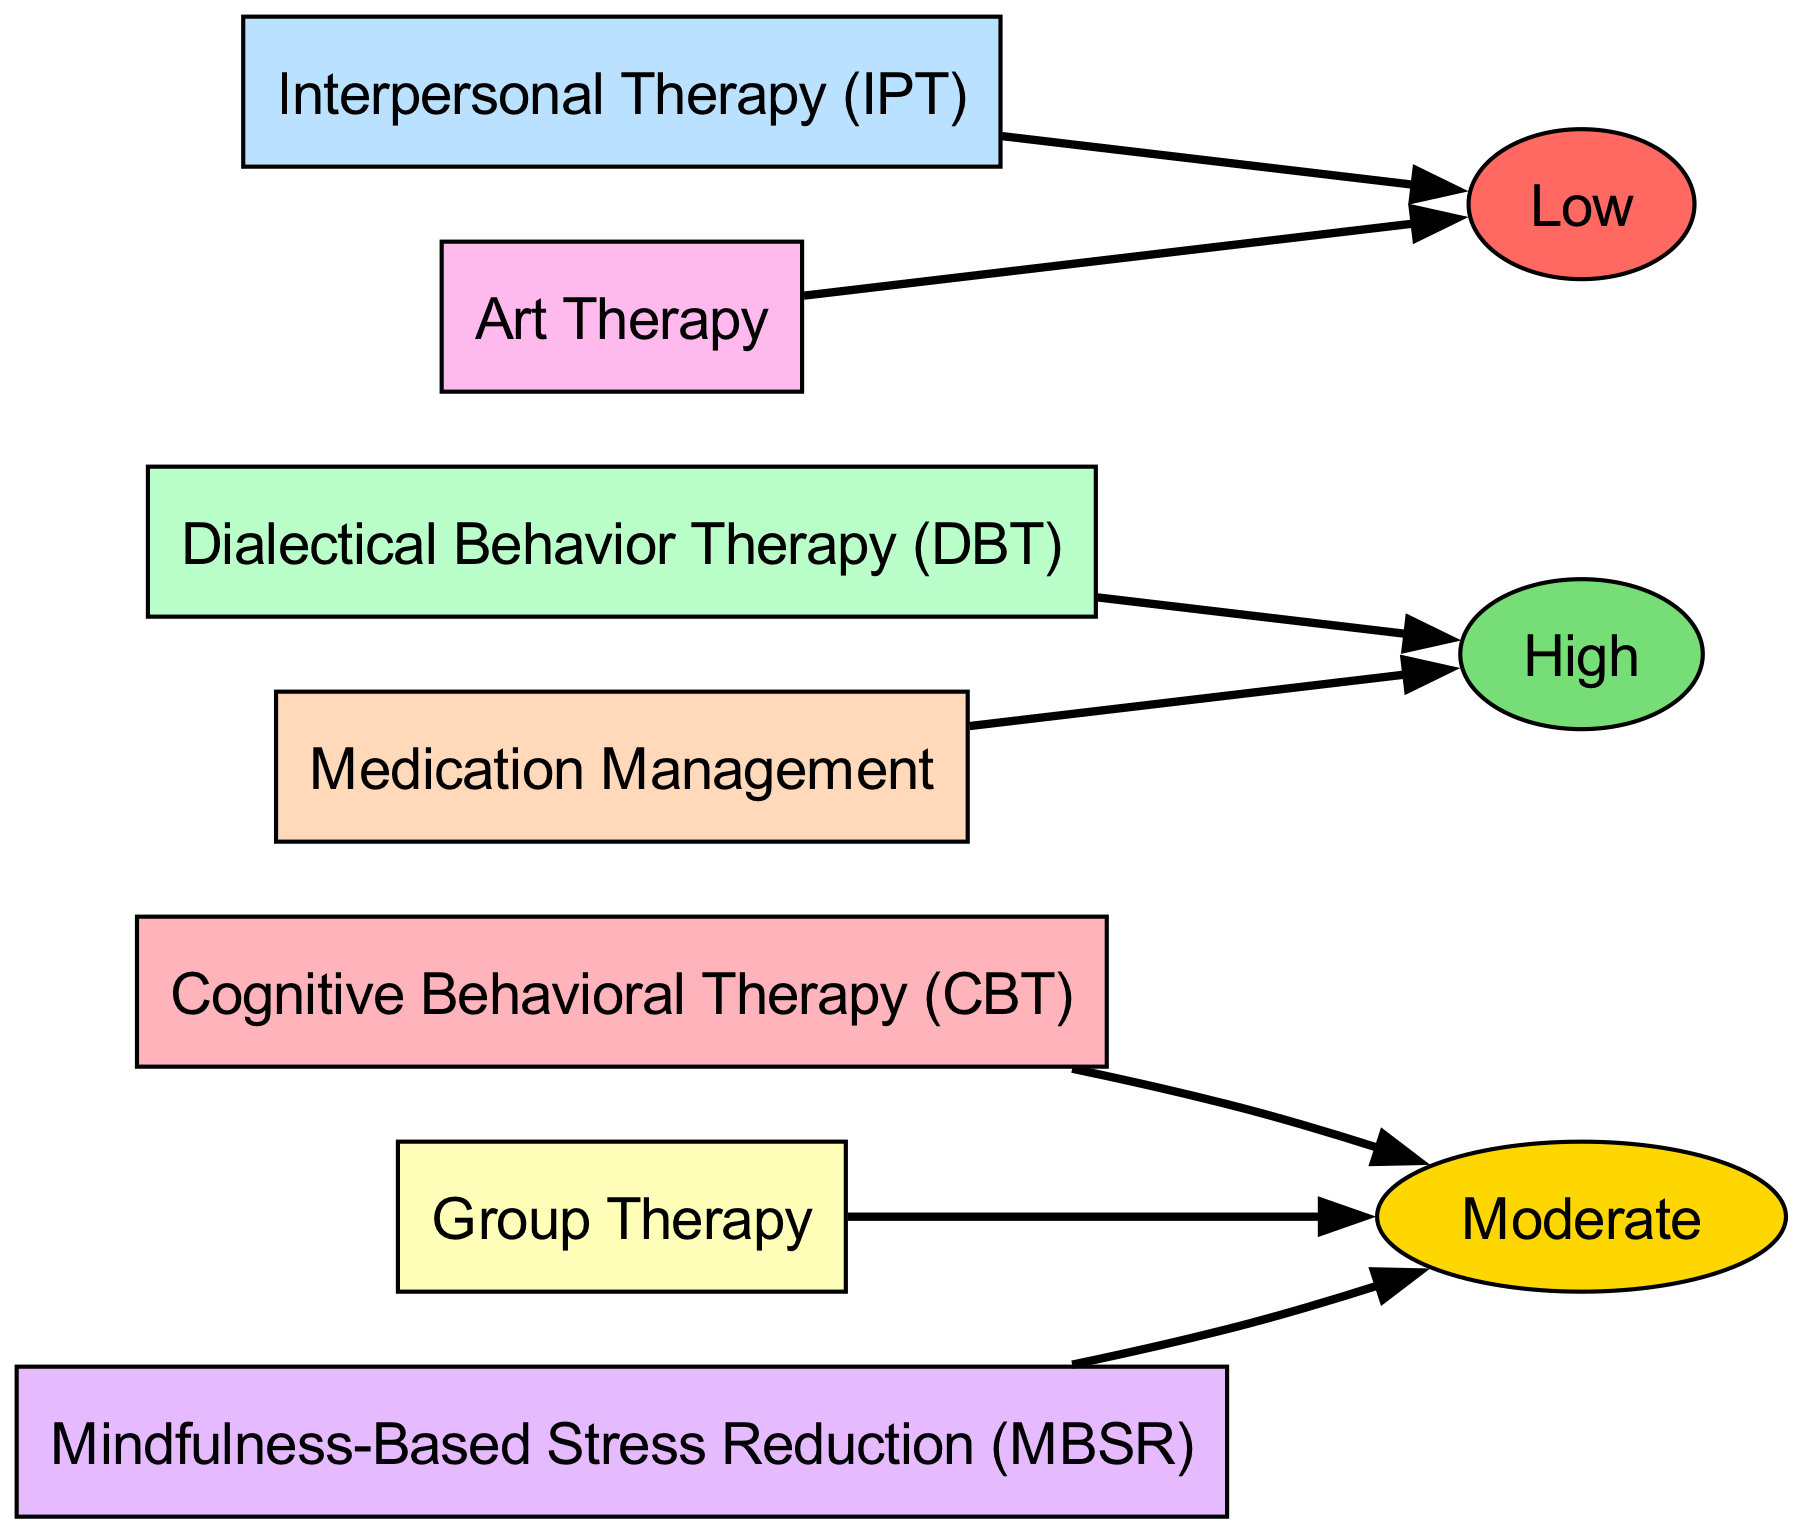What are the perceived effectiveness ratings present in the diagram? The diagram includes three distinct effectiveness ratings: Low, Moderate, and High. These are evident in the nodes that represent the perceived effectiveness levels associated with different therapy types.
Answer: Low, Moderate, High Which therapy type is associated with the highest perceived effectiveness? By examining the effectiveness nodes linked to the therapy types, Dialectical Behavior Therapy (DBT) and Medication Management both connect to the High effectiveness node. Among these, they are the only types associated with high effectiveness.
Answer: Dialectical Behavior Therapy (DBT), Medication Management How many therapy types experience moderate perceived effectiveness? There are four therapy types that are linked to the Moderate effectiveness node: Cognitive Behavioral Therapy (CBT), Group Therapy, and Mindfulness-Based Stress Reduction (MBSR). Counting these instances provides the numerical answer.
Answer: 3 What is the relationship between Interpersonal Therapy (IPT) and its perceived effectiveness? Interpersonal Therapy (IPT) connects directly to the Low effectiveness node, indicating that its perceived effectiveness is rated as low based on the diagram’s structure.
Answer: Low How many therapy types have a perceived effectiveness rating of Low? The diagram shows that there are two therapy types linked to the Low effectiveness node: Interpersonal Therapy (IPT) and Art Therapy. By counting these connections, the answer is derived.
Answer: 2 What color represents the Dialectical Behavior Therapy (DBT) node in the diagram? The diagram uses a specific color coding system, and the node for Dialectical Behavior Therapy (DBT) is filled with a color that corresponds to the custom color defined for it, which is a shade representing high effectiveness.
Answer: Light Green Which type of therapy has no connection to the High effectiveness node? By reviewing the connections in the diagram, Art Therapy and Interpersonal Therapy (IPT) do not link to the High effectiveness node, thus establishing that these therapy types are excluded from high effectiveness ratings.
Answer: Art Therapy, Interpersonal Therapy (IPT) How many total therapy session types are included in the diagram? The total number of therapy types can be determined by counting all the nodes representing different therapy sessions, visible in the diagram's left-hand side. Five unique session types are identified here.
Answer: 7 